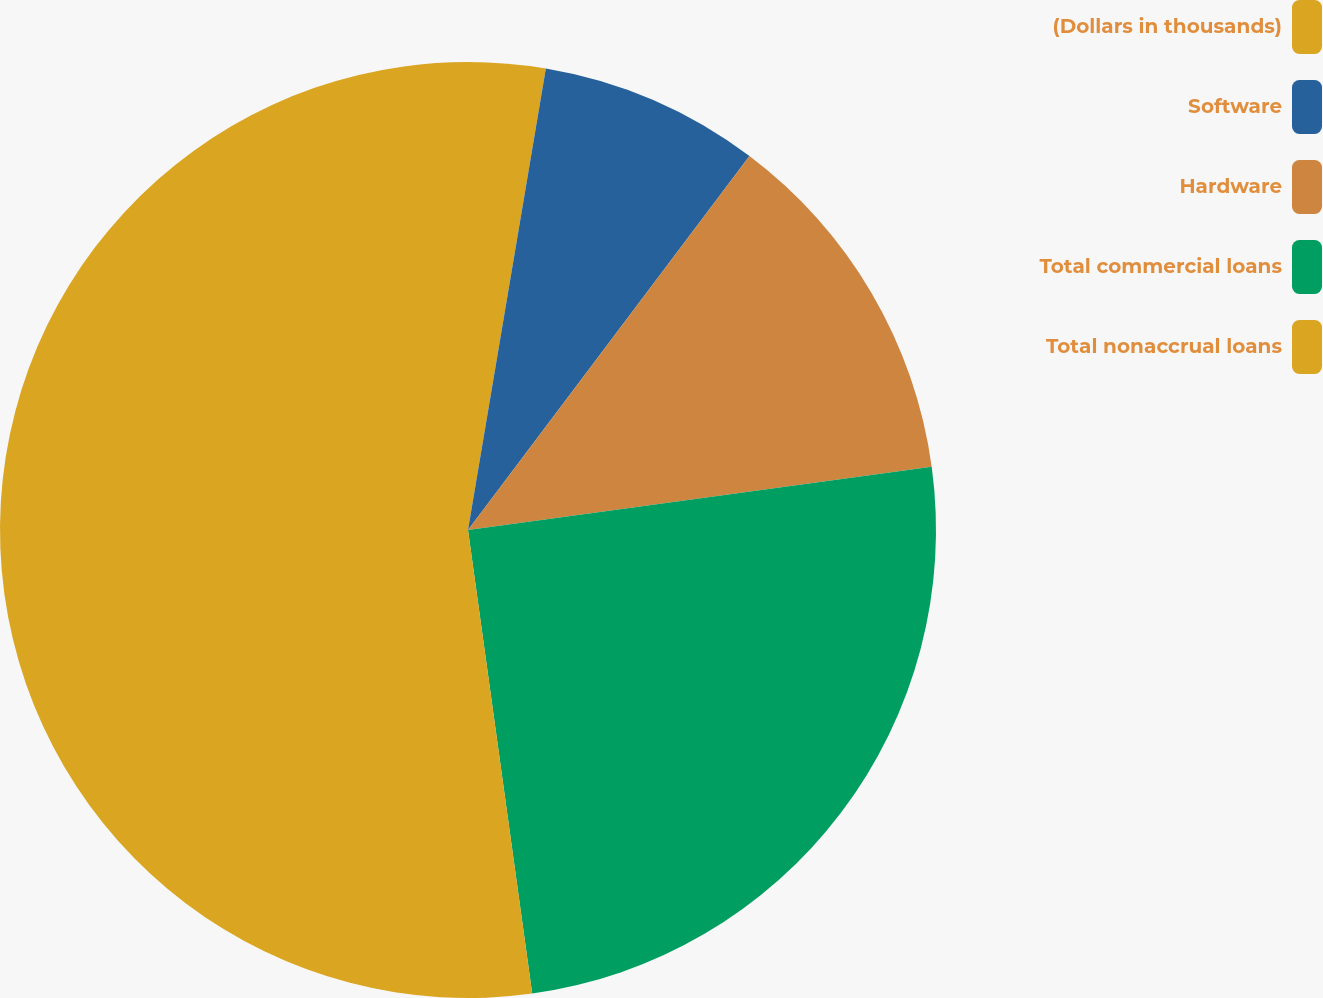<chart> <loc_0><loc_0><loc_500><loc_500><pie_chart><fcel>(Dollars in thousands)<fcel>Software<fcel>Hardware<fcel>Total commercial loans<fcel>Total nonaccrual loans<nl><fcel>2.66%<fcel>7.61%<fcel>12.57%<fcel>24.97%<fcel>52.19%<nl></chart> 